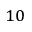Convert formula to latex. <formula><loc_0><loc_0><loc_500><loc_500>^ { 1 0 }</formula> 